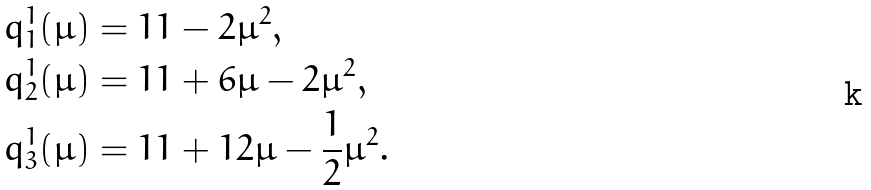<formula> <loc_0><loc_0><loc_500><loc_500>q _ { 1 } ^ { 1 } ( \mu ) & = 1 1 - 2 \mu ^ { 2 } , \\ q _ { 2 } ^ { 1 } ( \mu ) & = 1 1 + 6 \mu - 2 \mu ^ { 2 } , \\ q _ { 3 } ^ { 1 } ( \mu ) & = 1 1 + 1 2 \mu - \frac { 1 } { 2 } \mu ^ { 2 } .</formula> 